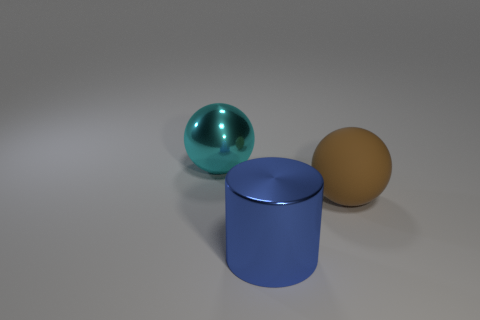Add 2 matte cylinders. How many objects exist? 5 Subtract all cylinders. How many objects are left? 2 Add 3 large matte objects. How many large matte objects exist? 4 Subtract 1 cyan spheres. How many objects are left? 2 Subtract all blue shiny objects. Subtract all brown rubber things. How many objects are left? 1 Add 3 cylinders. How many cylinders are left? 4 